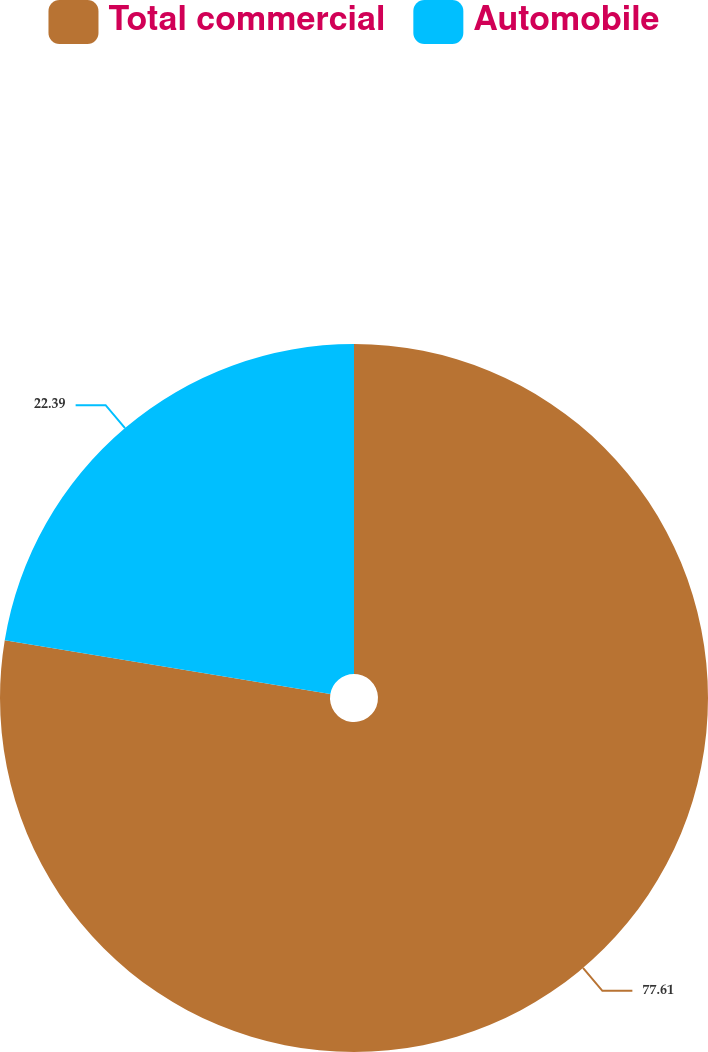<chart> <loc_0><loc_0><loc_500><loc_500><pie_chart><fcel>Total commercial<fcel>Automobile<nl><fcel>77.61%<fcel>22.39%<nl></chart> 